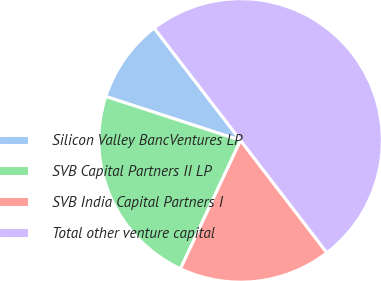Convert chart. <chart><loc_0><loc_0><loc_500><loc_500><pie_chart><fcel>Silicon Valley BancVentures LP<fcel>SVB Capital Partners II LP<fcel>SVB India Capital Partners I<fcel>Total other venture capital<nl><fcel>9.55%<fcel>23.04%<fcel>17.4%<fcel>50.0%<nl></chart> 